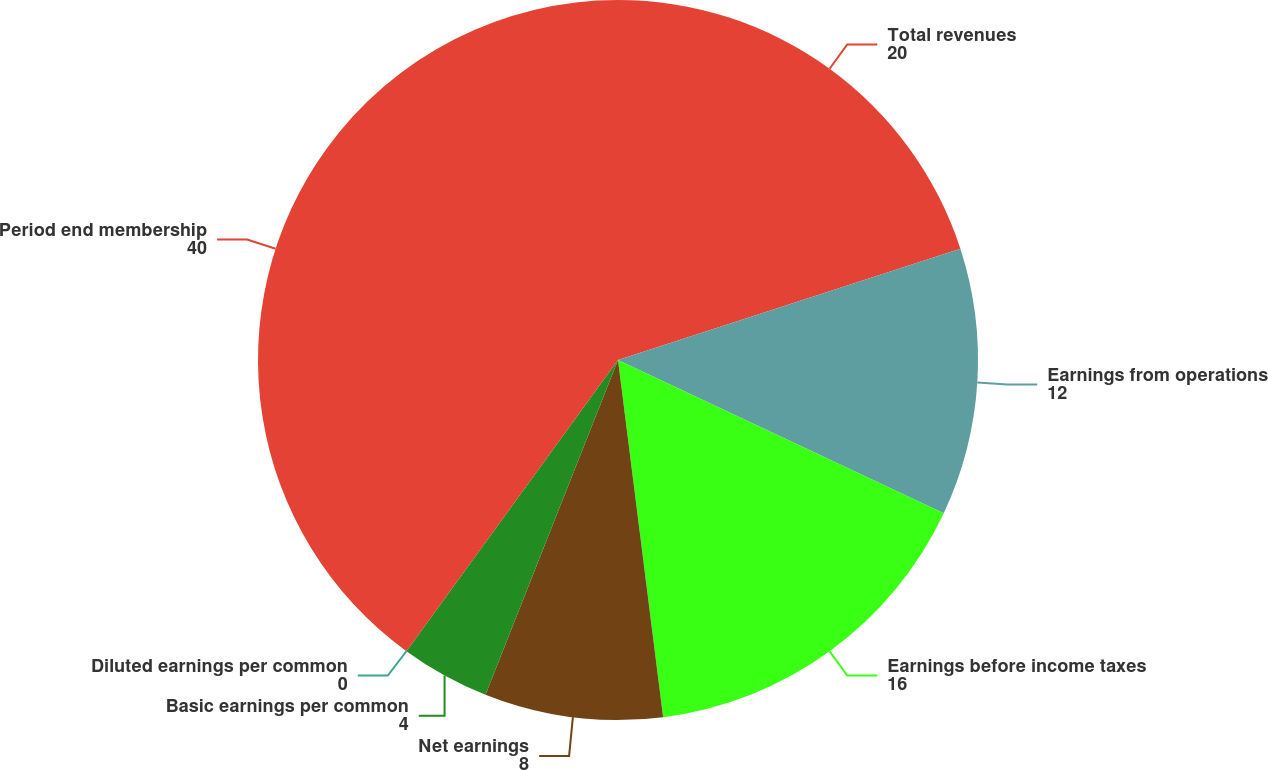Convert chart. <chart><loc_0><loc_0><loc_500><loc_500><pie_chart><fcel>Total revenues<fcel>Earnings from operations<fcel>Earnings before income taxes<fcel>Net earnings<fcel>Basic earnings per common<fcel>Diluted earnings per common<fcel>Period end membership<nl><fcel>20.0%<fcel>12.0%<fcel>16.0%<fcel>8.0%<fcel>4.0%<fcel>0.0%<fcel>40.0%<nl></chart> 